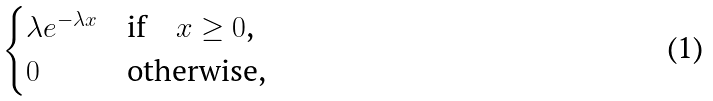<formula> <loc_0><loc_0><loc_500><loc_500>\begin{cases} \lambda e ^ { - \lambda x } & \text {if\quad $x\geq 0$,} \\ 0 & \text {otherwise,} \end{cases}</formula> 